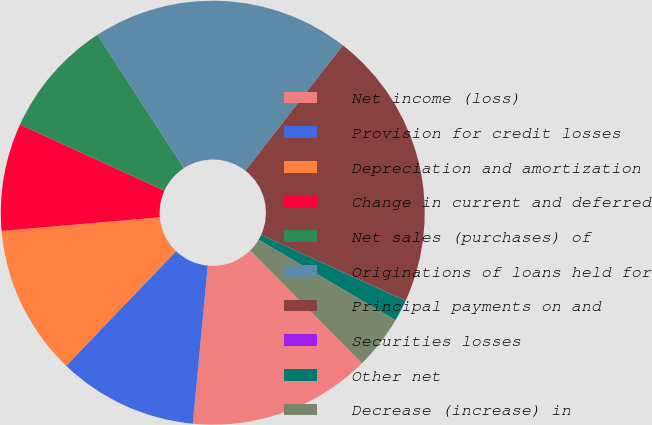<chart> <loc_0><loc_0><loc_500><loc_500><pie_chart><fcel>Net income (loss)<fcel>Provision for credit losses<fcel>Depreciation and amortization<fcel>Change in current and deferred<fcel>Net sales (purchases) of<fcel>Originations of loans held for<fcel>Principal payments on and<fcel>Securities losses<fcel>Other net<fcel>Decrease (increase) in<nl><fcel>13.93%<fcel>10.66%<fcel>11.47%<fcel>8.2%<fcel>9.02%<fcel>19.67%<fcel>21.3%<fcel>0.01%<fcel>1.65%<fcel>4.1%<nl></chart> 